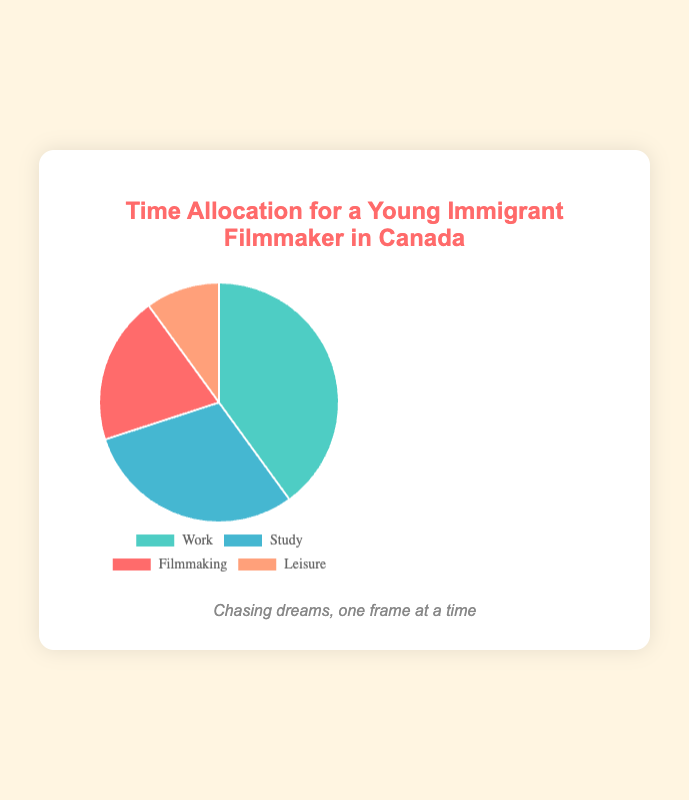Which activity takes up the most time for the young immigrants? By looking at the pie chart, the largest slice represents the activity with the highest allocation. In this case, it's "Work" which occupies 40%.
Answer: Work Which activity takes up the least time for the young immigrants? The smallest slice in the pie chart indicates the activity with the least time allocation. Here, "Leisure" takes up 10%.
Answer: Leisure How much more time is allocated to Work compared to Filmmaking? Work takes up 40% and Filmmaking takes up 20%. Subtract the percentage of Filmmaking from Work: 40% - 20% = 20%.
Answer: 20% What is the total time allocated to Study and Filmmaking combined? The allocation for Study is 30% and for Filmmaking is 20%. Add these percentages together: 30% + 20% = 50%.
Answer: 50% If time allocated to Study increased by 10%, what would the new allocation be? The current allocation for Study is 30%. Adding 10% to this allocation gives: 30% + 10% = 40%.
Answer: 40% Which activities combined have the same time allocation as Work? Work is allocated 40% of the time. Study and Filmmaking combined also sum up to 40% (30% + 10%).
Answer: Study and Filmmaking Which activity is represented by the red section of the pie chart? The red section of the pie chart corresponds to "Filmmaking" as indicated by the color legend.
Answer: Filmmaking What is the difference in time allocation between Study and Leisure? Study takes up 30% and Leisure takes up 10%. Subtract Leisure's percentage from Study's: 30% - 10% = 20%.
Answer: 20% Compare the time allocation for Filmmaking and Leisure. Which one is greater and by how much? Filmmaking takes up 20% and Leisure takes up 10%. Subtract Leisure's percentage from Filmmaking's: 20% - 10% = 10%. Filmmaking is greater by 10%.
Answer: Filmmaking by 10% 